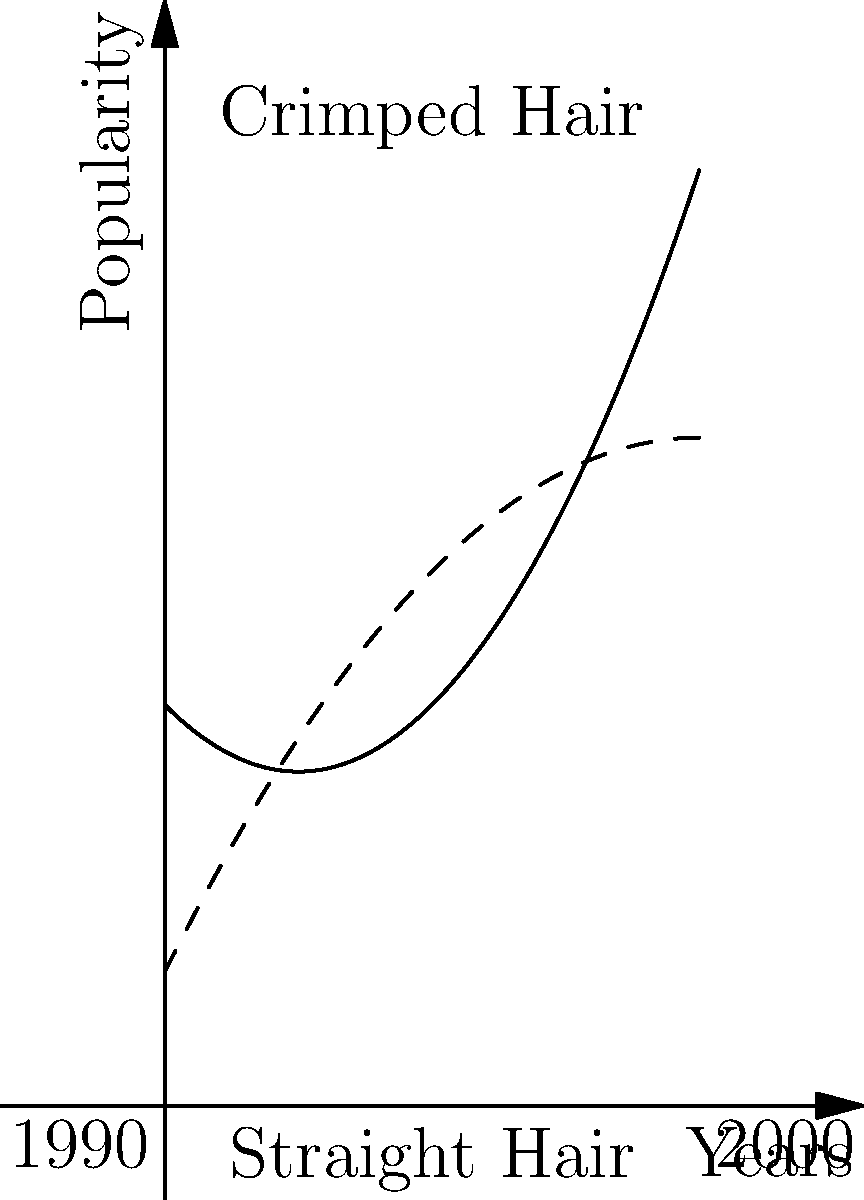Like, OMG! Check out this totally rad graph showing the popularity of crimped hair (solid line) and straight hair (dashed line) from 1990 to 2000. Can you calculate the difference in popularity between these two awesome styles over the decade? Use the area between the curves to find out! Okay, let's break this down step by step:

1) The solid line (crimped hair) is represented by $f(x) = 0.5x^2 - x + 3$
   The dashed line (straight hair) is represented by $g(x) = -0.25x^2 + 2x + 1$

2) To find the area between the curves, we need to integrate the difference of these functions:

   Area = $\int_0^4 [f(x) - g(x)] dx$

3) Let's substitute our functions:

   Area = $\int_0^4 [(0.5x^2 - x + 3) - (-0.25x^2 + 2x + 1)] dx$

4) Simplify inside the integral:

   Area = $\int_0^4 [0.75x^2 - 3x + 2] dx$

5) Now, let's integrate:

   Area = $[0.25x^3 - 1.5x^2 + 2x]_0^4$

6) Evaluate at the limits:

   Area = $(0.25(4^3) - 1.5(4^2) + 2(4)) - (0.25(0^3) - 1.5(0^2) + 2(0))$
        = $(16 - 24 + 8) - (0 - 0 + 0)$
        = $0$

7) The area between the curves is 0 square units!
Answer: 0 square units 